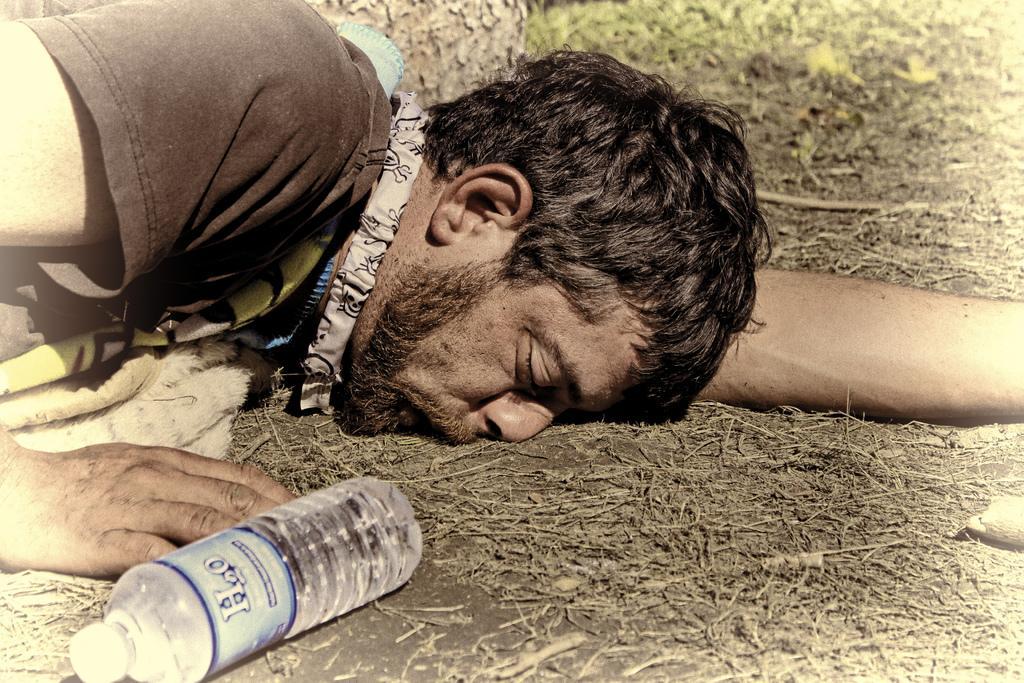In one or two sentences, can you explain what this image depicts? The person wearing black shirt slept on the ground, His nose and lips were touched to the ground and there is also a water bottle on the left bottom and there is grass on the top right in the background 